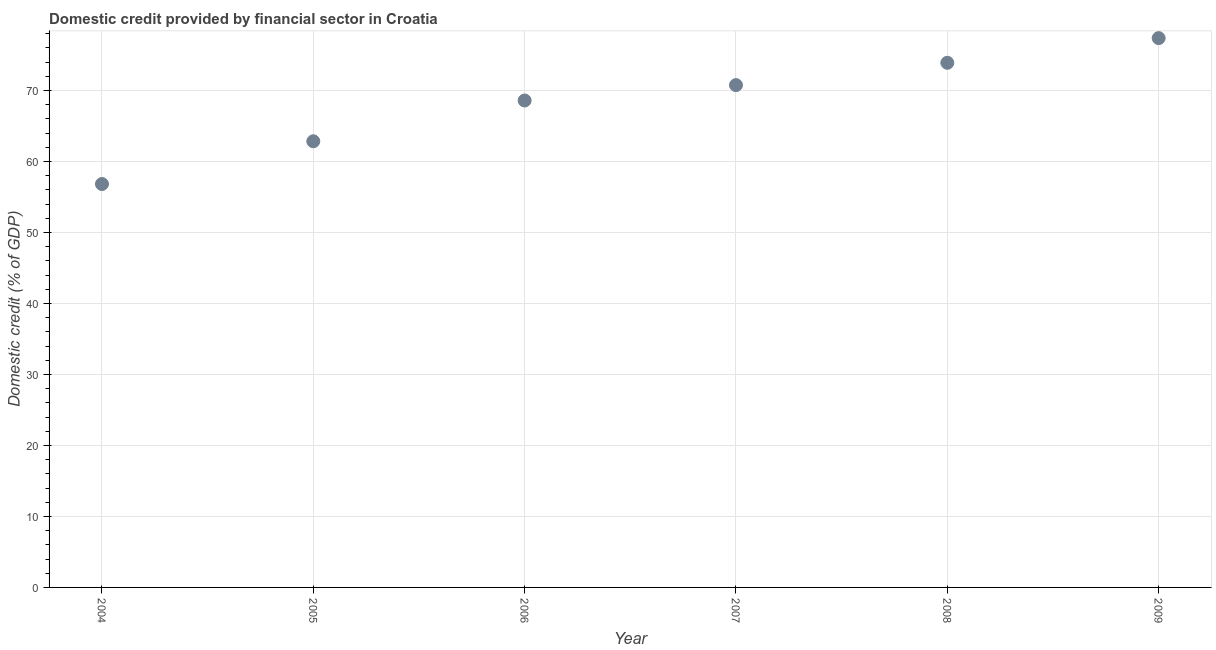What is the domestic credit provided by financial sector in 2009?
Ensure brevity in your answer.  77.38. Across all years, what is the maximum domestic credit provided by financial sector?
Provide a short and direct response. 77.38. Across all years, what is the minimum domestic credit provided by financial sector?
Keep it short and to the point. 56.83. In which year was the domestic credit provided by financial sector maximum?
Offer a very short reply. 2009. In which year was the domestic credit provided by financial sector minimum?
Provide a succinct answer. 2004. What is the sum of the domestic credit provided by financial sector?
Your answer should be very brief. 410.29. What is the difference between the domestic credit provided by financial sector in 2005 and 2008?
Provide a succinct answer. -11.05. What is the average domestic credit provided by financial sector per year?
Offer a very short reply. 68.38. What is the median domestic credit provided by financial sector?
Your answer should be very brief. 69.67. Do a majority of the years between 2007 and 2004 (inclusive) have domestic credit provided by financial sector greater than 54 %?
Make the answer very short. Yes. What is the ratio of the domestic credit provided by financial sector in 2004 to that in 2006?
Provide a succinct answer. 0.83. Is the domestic credit provided by financial sector in 2007 less than that in 2008?
Provide a short and direct response. Yes. Is the difference between the domestic credit provided by financial sector in 2004 and 2007 greater than the difference between any two years?
Keep it short and to the point. No. What is the difference between the highest and the second highest domestic credit provided by financial sector?
Keep it short and to the point. 3.48. Is the sum of the domestic credit provided by financial sector in 2004 and 2005 greater than the maximum domestic credit provided by financial sector across all years?
Your answer should be compact. Yes. What is the difference between the highest and the lowest domestic credit provided by financial sector?
Make the answer very short. 20.55. How many years are there in the graph?
Your response must be concise. 6. What is the difference between two consecutive major ticks on the Y-axis?
Keep it short and to the point. 10. Does the graph contain any zero values?
Offer a terse response. No. What is the title of the graph?
Your response must be concise. Domestic credit provided by financial sector in Croatia. What is the label or title of the Y-axis?
Provide a succinct answer. Domestic credit (% of GDP). What is the Domestic credit (% of GDP) in 2004?
Offer a terse response. 56.83. What is the Domestic credit (% of GDP) in 2005?
Give a very brief answer. 62.85. What is the Domestic credit (% of GDP) in 2006?
Provide a succinct answer. 68.59. What is the Domestic credit (% of GDP) in 2007?
Your answer should be compact. 70.76. What is the Domestic credit (% of GDP) in 2008?
Offer a terse response. 73.9. What is the Domestic credit (% of GDP) in 2009?
Make the answer very short. 77.38. What is the difference between the Domestic credit (% of GDP) in 2004 and 2005?
Your answer should be very brief. -6.02. What is the difference between the Domestic credit (% of GDP) in 2004 and 2006?
Keep it short and to the point. -11.76. What is the difference between the Domestic credit (% of GDP) in 2004 and 2007?
Keep it short and to the point. -13.93. What is the difference between the Domestic credit (% of GDP) in 2004 and 2008?
Make the answer very short. -17.07. What is the difference between the Domestic credit (% of GDP) in 2004 and 2009?
Your answer should be compact. -20.55. What is the difference between the Domestic credit (% of GDP) in 2005 and 2006?
Make the answer very short. -5.74. What is the difference between the Domestic credit (% of GDP) in 2005 and 2007?
Offer a terse response. -7.91. What is the difference between the Domestic credit (% of GDP) in 2005 and 2008?
Offer a terse response. -11.05. What is the difference between the Domestic credit (% of GDP) in 2005 and 2009?
Make the answer very short. -14.53. What is the difference between the Domestic credit (% of GDP) in 2006 and 2007?
Offer a terse response. -2.17. What is the difference between the Domestic credit (% of GDP) in 2006 and 2008?
Make the answer very short. -5.31. What is the difference between the Domestic credit (% of GDP) in 2006 and 2009?
Provide a short and direct response. -8.79. What is the difference between the Domestic credit (% of GDP) in 2007 and 2008?
Provide a short and direct response. -3.14. What is the difference between the Domestic credit (% of GDP) in 2007 and 2009?
Make the answer very short. -6.62. What is the difference between the Domestic credit (% of GDP) in 2008 and 2009?
Offer a terse response. -3.48. What is the ratio of the Domestic credit (% of GDP) in 2004 to that in 2005?
Offer a very short reply. 0.9. What is the ratio of the Domestic credit (% of GDP) in 2004 to that in 2006?
Keep it short and to the point. 0.83. What is the ratio of the Domestic credit (% of GDP) in 2004 to that in 2007?
Provide a short and direct response. 0.8. What is the ratio of the Domestic credit (% of GDP) in 2004 to that in 2008?
Your response must be concise. 0.77. What is the ratio of the Domestic credit (% of GDP) in 2004 to that in 2009?
Ensure brevity in your answer.  0.73. What is the ratio of the Domestic credit (% of GDP) in 2005 to that in 2006?
Offer a terse response. 0.92. What is the ratio of the Domestic credit (% of GDP) in 2005 to that in 2007?
Offer a very short reply. 0.89. What is the ratio of the Domestic credit (% of GDP) in 2005 to that in 2008?
Give a very brief answer. 0.85. What is the ratio of the Domestic credit (% of GDP) in 2005 to that in 2009?
Offer a very short reply. 0.81. What is the ratio of the Domestic credit (% of GDP) in 2006 to that in 2008?
Provide a short and direct response. 0.93. What is the ratio of the Domestic credit (% of GDP) in 2006 to that in 2009?
Your answer should be very brief. 0.89. What is the ratio of the Domestic credit (% of GDP) in 2007 to that in 2009?
Offer a terse response. 0.91. What is the ratio of the Domestic credit (% of GDP) in 2008 to that in 2009?
Offer a very short reply. 0.95. 